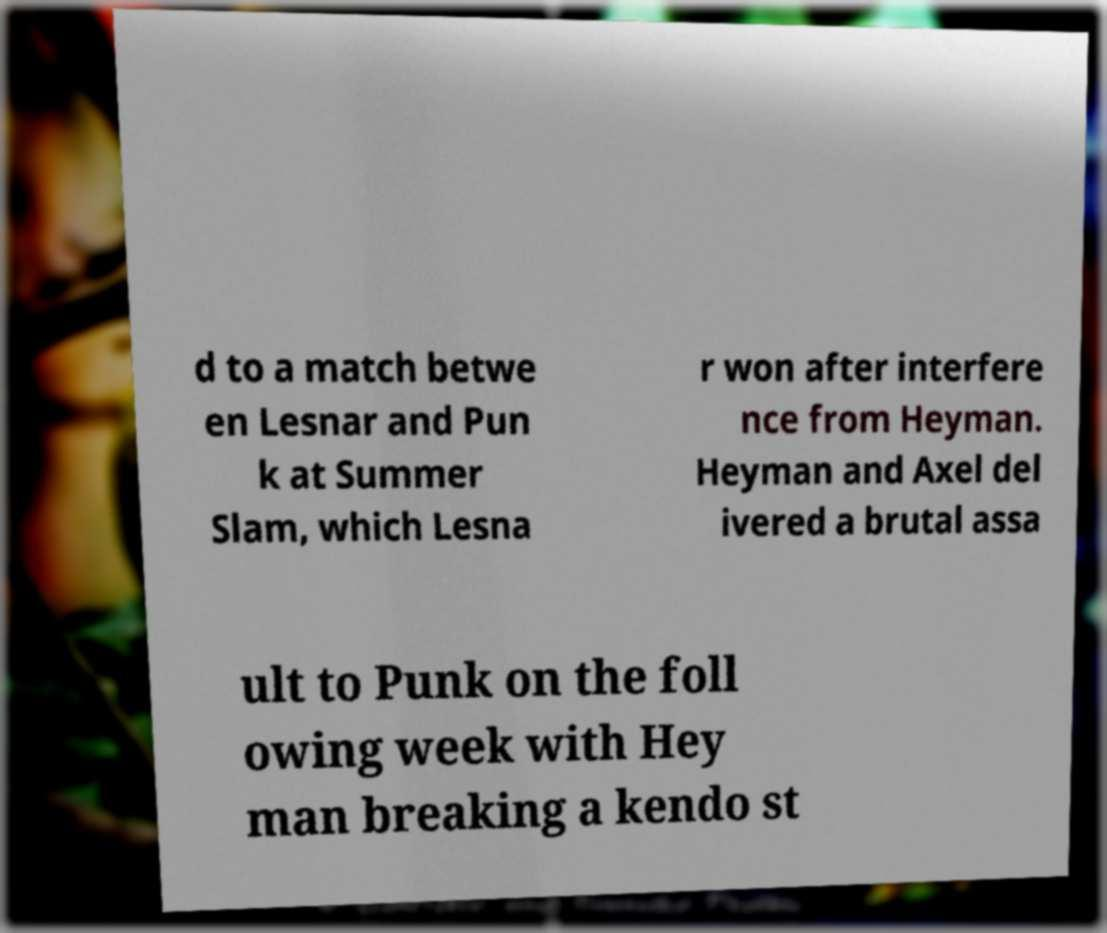What messages or text are displayed in this image? I need them in a readable, typed format. d to a match betwe en Lesnar and Pun k at Summer Slam, which Lesna r won after interfere nce from Heyman. Heyman and Axel del ivered a brutal assa ult to Punk on the foll owing week with Hey man breaking a kendo st 